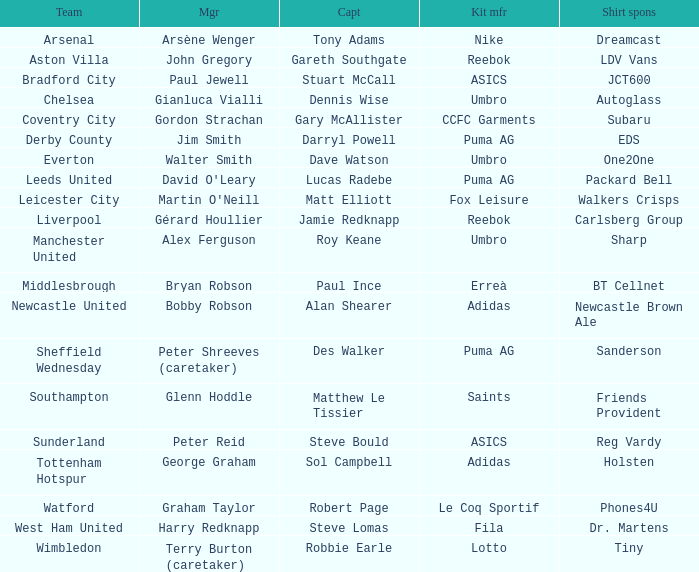Which shirt sponser has Nike as a kit manufacturer? Dreamcast. 